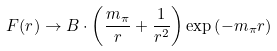<formula> <loc_0><loc_0><loc_500><loc_500>F ( r ) \rightarrow B \cdot \left ( \frac { m _ { \pi } } { r } + \frac { 1 } { r ^ { 2 } } \right ) \exp \left ( - m _ { \pi } r \right )</formula> 